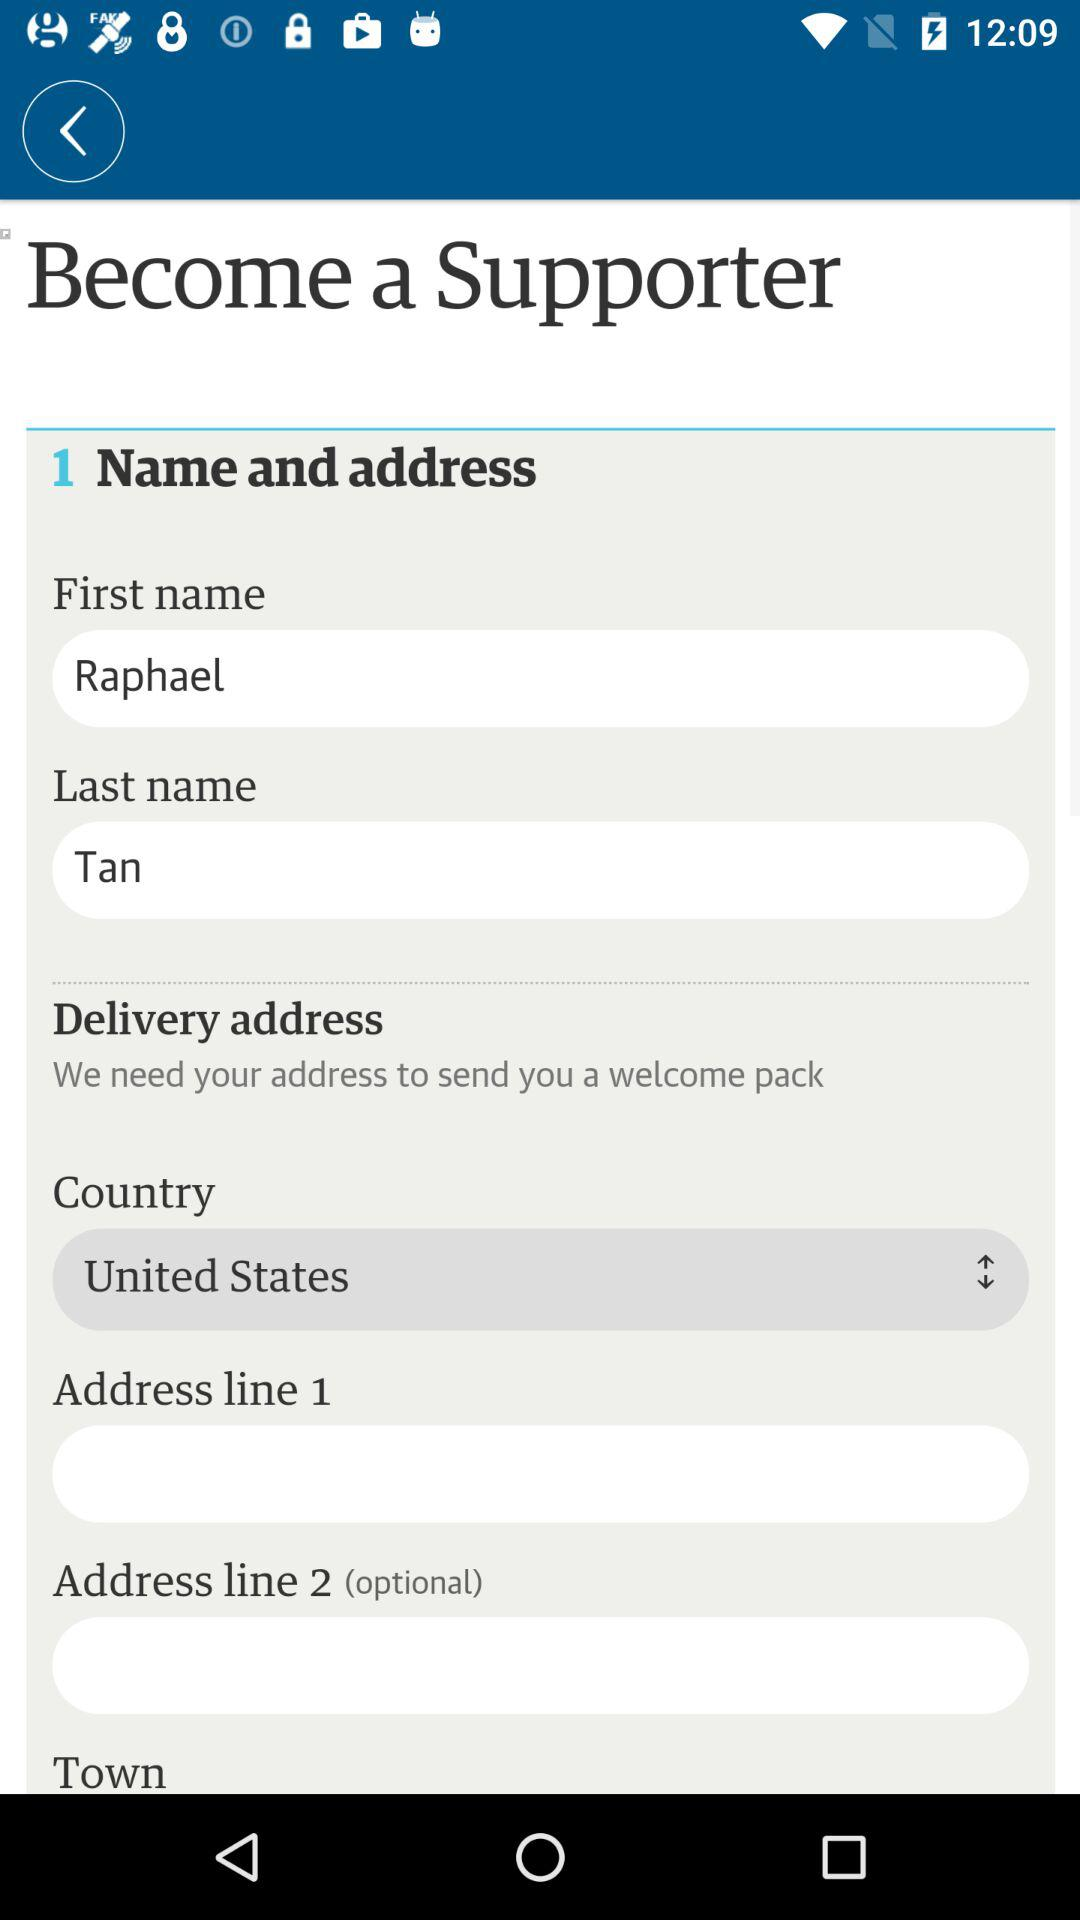What is the last name? The last name is Tan. 